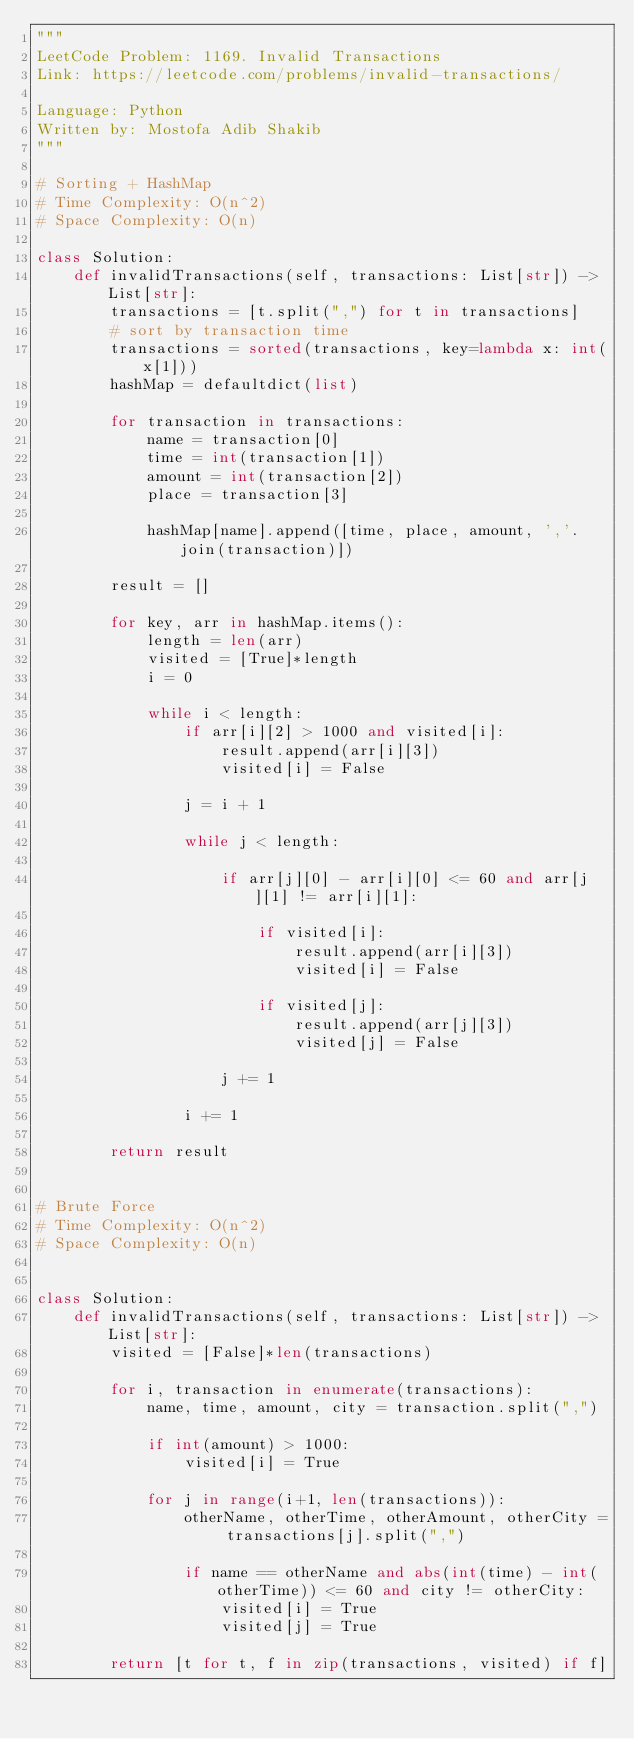Convert code to text. <code><loc_0><loc_0><loc_500><loc_500><_Python_>"""
LeetCode Problem: 1169. Invalid Transactions
Link: https://leetcode.com/problems/invalid-transactions/

Language: Python
Written by: Mostofa Adib Shakib
"""

# Sorting + HashMap
# Time Complexity: O(n^2)
# Space Complexity: O(n)

class Solution:
    def invalidTransactions(self, transactions: List[str]) -> List[str]:
        transactions = [t.split(",") for t in transactions]
        # sort by transaction time
        transactions = sorted(transactions, key=lambda x: int(x[1]))
        hashMap = defaultdict(list)
                
        for transaction in transactions:
            name = transaction[0]
            time = int(transaction[1])
            amount = int(transaction[2])
            place = transaction[3]
                        
            hashMap[name].append([time, place, amount, ','.join(transaction)])
        
        result = []
                
        for key, arr in hashMap.items():
            length = len(arr)
            visited = [True]*length
            i = 0
                                    
            while i < length:
                if arr[i][2] > 1000 and visited[i]:
                    result.append(arr[i][3])
                    visited[i] = False

                j = i + 1

                while j < length:                    

                    if arr[j][0] - arr[i][0] <= 60 and arr[j][1] != arr[i][1]:

                        if visited[i]:
                            result.append(arr[i][3])
                            visited[i] = False

                        if visited[j]:
                            result.append(arr[j][3])
                            visited[j] = False

                    j += 1

                i += 1

        return result


# Brute Force
# Time Complexity: O(n^2)
# Space Complexity: O(n)


class Solution:
    def invalidTransactions(self, transactions: List[str]) -> List[str]:
        visited = [False]*len(transactions)
        
        for i, transaction in enumerate(transactions): 
            name, time, amount, city = transaction.split(",")

            if int(amount) > 1000:
                visited[i] = True
                
            for j in range(i+1, len(transactions)): 
                otherName, otherTime, otherAmount, otherCity = transactions[j].split(",")
                
                if name == otherName and abs(int(time) - int(otherTime)) <= 60 and city != otherCity:
                    visited[i] = True
                    visited[j] = True
                    
        return [t for t, f in zip(transactions, visited) if f]</code> 